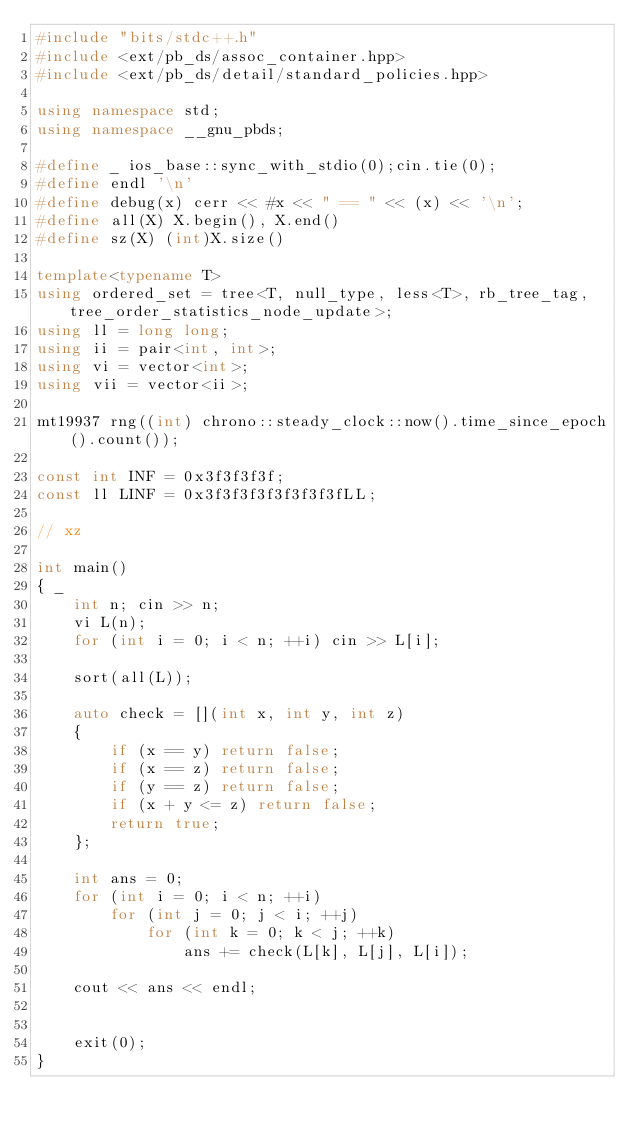<code> <loc_0><loc_0><loc_500><loc_500><_C++_>#include "bits/stdc++.h"
#include <ext/pb_ds/assoc_container.hpp>
#include <ext/pb_ds/detail/standard_policies.hpp>

using namespace std;
using namespace __gnu_pbds;

#define _ ios_base::sync_with_stdio(0);cin.tie(0);
#define endl '\n'
#define debug(x) cerr << #x << " == " << (x) << '\n';
#define all(X) X.begin(), X.end()
#define sz(X) (int)X.size()

template<typename T>
using ordered_set = tree<T, null_type, less<T>, rb_tree_tag, tree_order_statistics_node_update>;
using ll = long long;
using ii = pair<int, int>;
using vi = vector<int>;
using vii = vector<ii>;

mt19937 rng((int) chrono::steady_clock::now().time_since_epoch().count());

const int INF = 0x3f3f3f3f;
const ll LINF = 0x3f3f3f3f3f3f3f3fLL;

// xz

int main()
{ _
    int n; cin >> n;
    vi L(n);
    for (int i = 0; i < n; ++i) cin >> L[i];

    sort(all(L));

    auto check = [](int x, int y, int z)
    {
        if (x == y) return false;
        if (x == z) return false;
        if (y == z) return false;
        if (x + y <= z) return false;
        return true;
    };

    int ans = 0;
    for (int i = 0; i < n; ++i)
        for (int j = 0; j < i; ++j)
            for (int k = 0; k < j; ++k)
                ans += check(L[k], L[j], L[i]);

    cout << ans << endl;


    exit(0);
}

</code> 